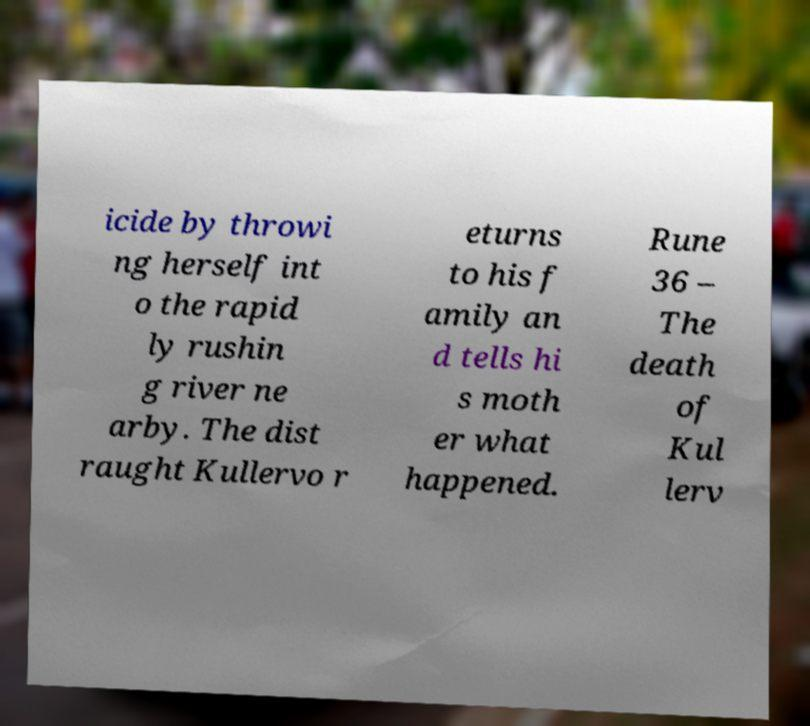Can you read and provide the text displayed in the image?This photo seems to have some interesting text. Can you extract and type it out for me? icide by throwi ng herself int o the rapid ly rushin g river ne arby. The dist raught Kullervo r eturns to his f amily an d tells hi s moth er what happened. Rune 36 – The death of Kul lerv 